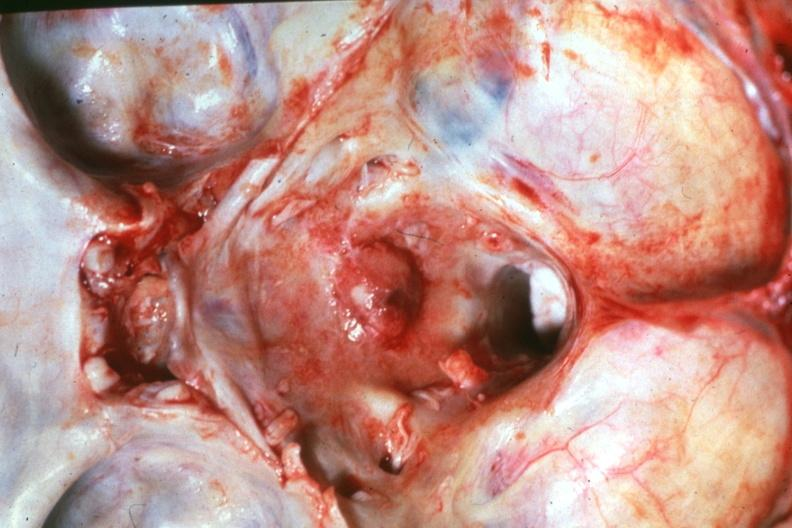what is present?
Answer the question using a single word or phrase. Bone, calvarium 